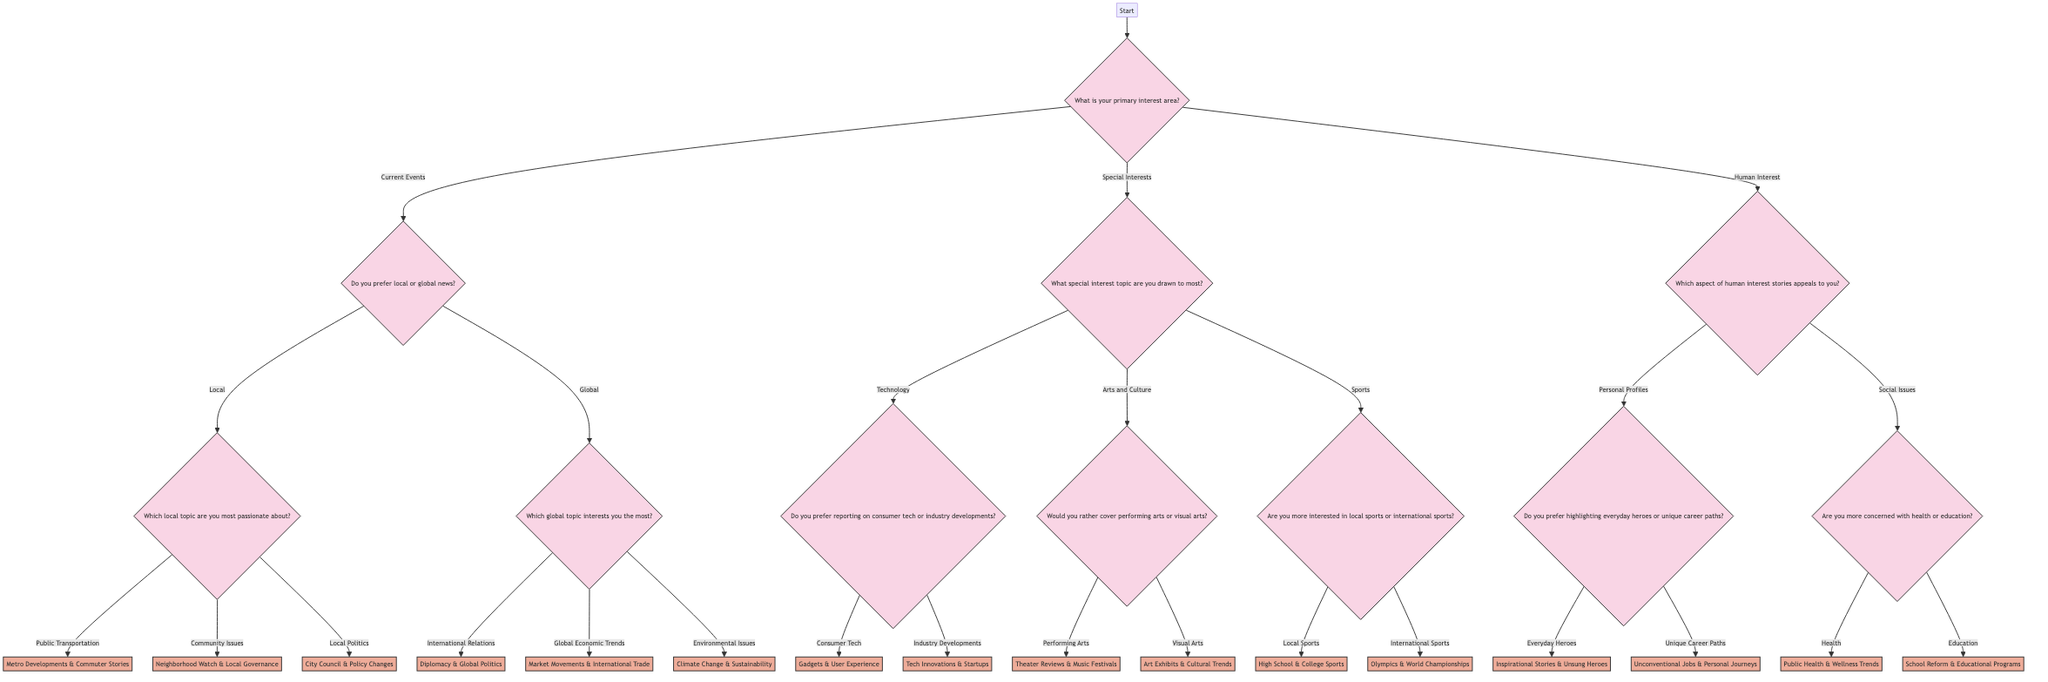What is the primary interest area in the diagram? The diagram starts with a node that asks "What is your primary interest area?" which is the first question at the start of the decision tree.
Answer: primary interest area How many branches emerge from the "Start" node? The "Start" node leads to three major branches: Current Events, Special Interests, and Human Interest. Counting these branches gives a total of three.
Answer: 3 What reporting beat is associated with Local Politics? Following the branch for Local under Current Events, the next question leads to Local Politics, which results in the Reporting Beat being "City Council & Policy Changes."
Answer: City Council & Policy Changes If a reporter chooses Technology as a special interest, what are the two categories they will consider? After selecting Technology, the next question asks whether they prefer reporting on consumer tech or industry developments, indicating that those are the two categories under Technology.
Answer: consumer tech or industry developments What would a reporter focusing on Environmental Issues be covering? The path from Global to Environmental Issues indicates that the Reporting Beat for this choice is "Climate Change & Sustainability."
Answer: Climate Change & Sustainability What is the Reporting Beat for highlighting Everyday Heroes? The decision tree directs from the node regarding Personal Profiles, where the choice for Everyday Heroes leads to the Reporting Beat being "Inspirational Stories & Unsung Heroes."
Answer: Inspirational Stories & Unsung Heroes What is the final node if a reporter prefers to cover local sports? Choosing Local Sports after selecting Sports leads to the final reporting beat: "High School & College Sports."
Answer: High School & College Sports How many reporting beats are mentioned for the "Special Interests" category? Under Special Interests, there are three main topics: Technology, Arts and Culture, and Sports. Each of these categories branches out into two reporting beats, resulting in a total of six reporting beats.
Answer: 6 What type of stories does the beat "School Reform & Educational Programs" focus on? This beat emerges from the Human Interest category when the focus is on education, indicating that it addresses issues related to educational reforms and programs.
Answer: educational programs 